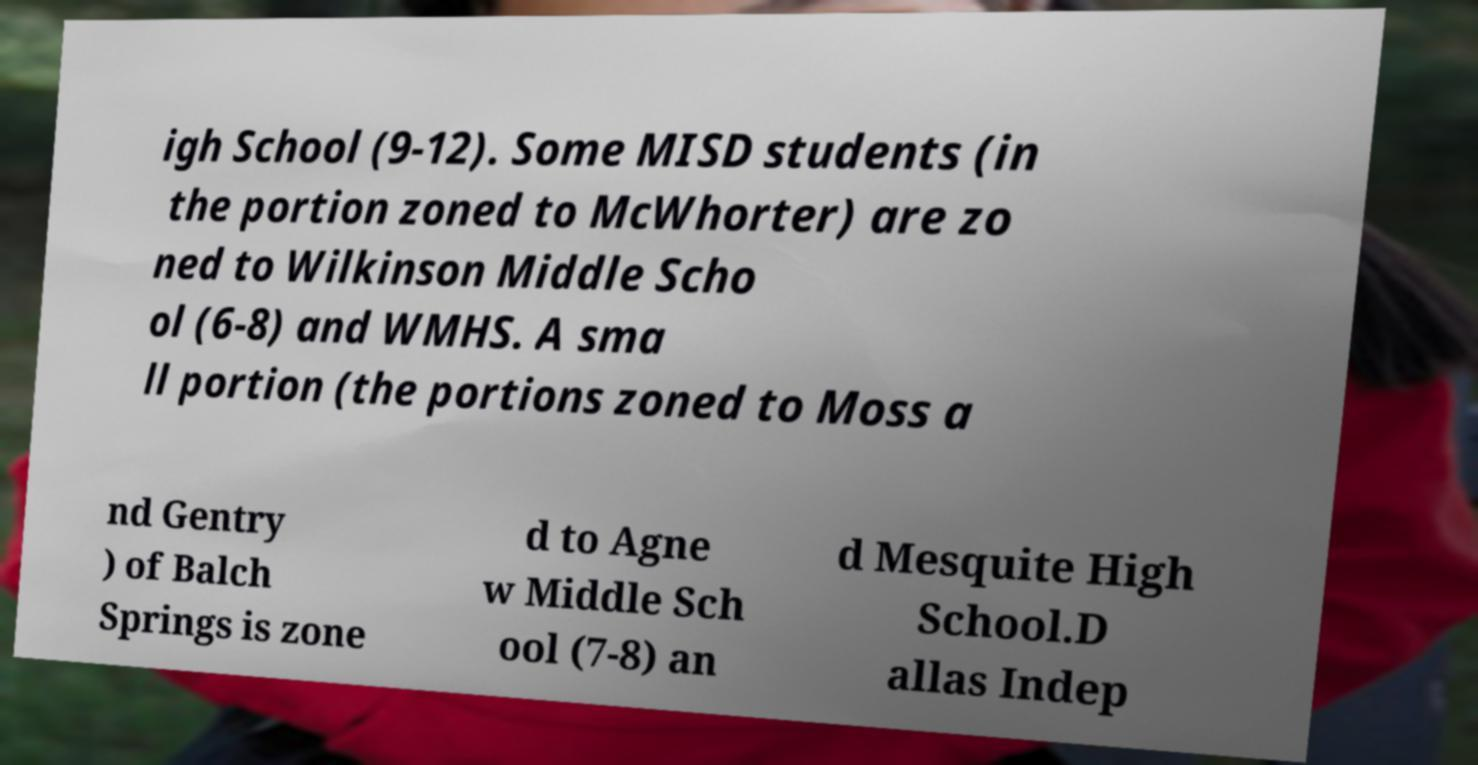Can you read and provide the text displayed in the image?This photo seems to have some interesting text. Can you extract and type it out for me? igh School (9-12). Some MISD students (in the portion zoned to McWhorter) are zo ned to Wilkinson Middle Scho ol (6-8) and WMHS. A sma ll portion (the portions zoned to Moss a nd Gentry ) of Balch Springs is zone d to Agne w Middle Sch ool (7-8) an d Mesquite High School.D allas Indep 